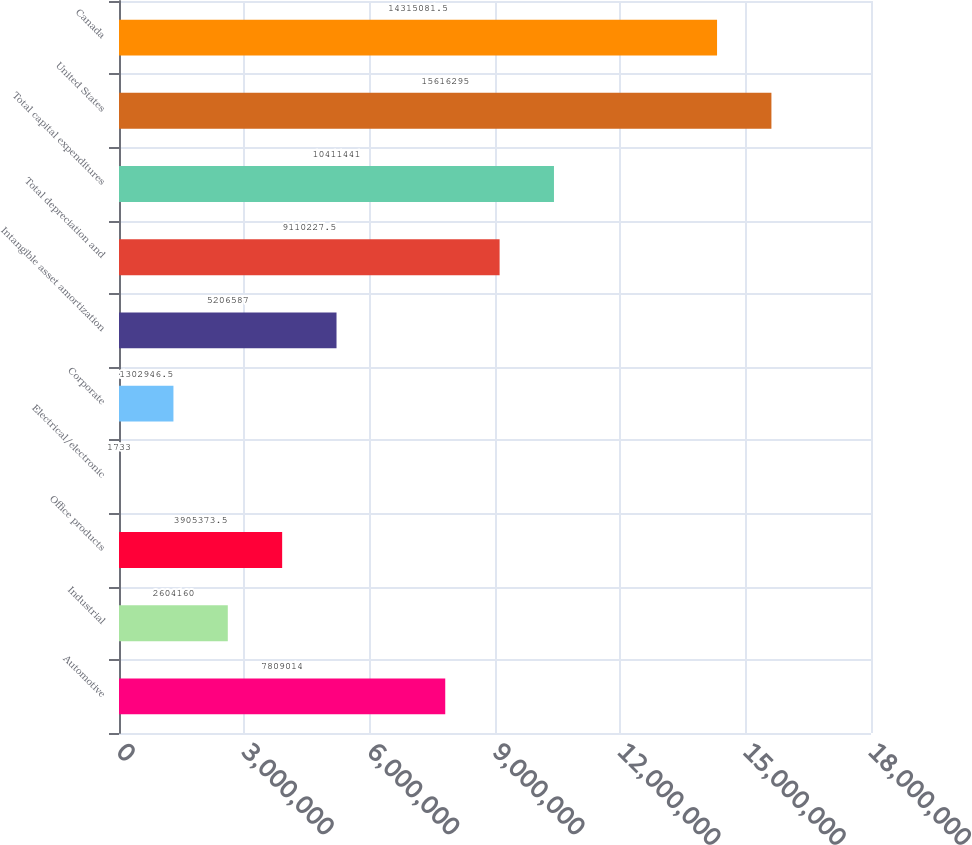Convert chart to OTSL. <chart><loc_0><loc_0><loc_500><loc_500><bar_chart><fcel>Automotive<fcel>Industrial<fcel>Office products<fcel>Electrical/electronic<fcel>Corporate<fcel>Intangible asset amortization<fcel>Total depreciation and<fcel>Total capital expenditures<fcel>United States<fcel>Canada<nl><fcel>7.80901e+06<fcel>2.60416e+06<fcel>3.90537e+06<fcel>1733<fcel>1.30295e+06<fcel>5.20659e+06<fcel>9.11023e+06<fcel>1.04114e+07<fcel>1.56163e+07<fcel>1.43151e+07<nl></chart> 